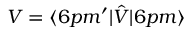Convert formula to latex. <formula><loc_0><loc_0><loc_500><loc_500>V = \langle 6 p m ^ { \prime } | \hat { V } | 6 p m \rangle</formula> 